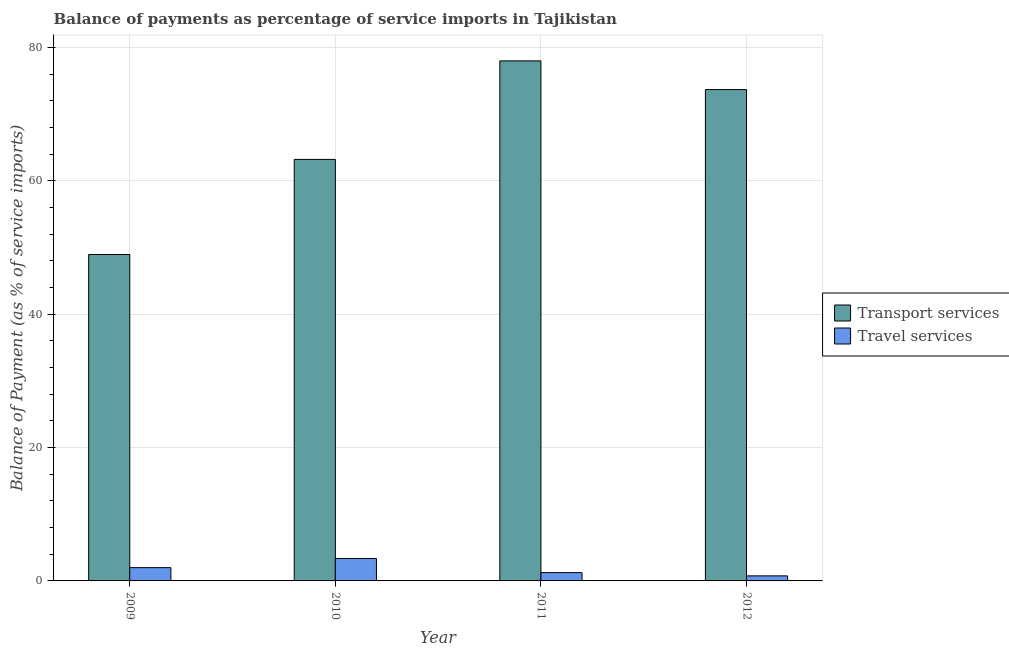How many groups of bars are there?
Your response must be concise. 4. Are the number of bars per tick equal to the number of legend labels?
Make the answer very short. Yes. What is the balance of payments of transport services in 2010?
Provide a short and direct response. 63.21. Across all years, what is the maximum balance of payments of travel services?
Provide a short and direct response. 3.36. Across all years, what is the minimum balance of payments of transport services?
Your answer should be compact. 48.95. In which year was the balance of payments of travel services maximum?
Offer a terse response. 2010. What is the total balance of payments of transport services in the graph?
Offer a terse response. 263.83. What is the difference between the balance of payments of transport services in 2009 and that in 2010?
Offer a very short reply. -14.26. What is the difference between the balance of payments of travel services in 2011 and the balance of payments of transport services in 2009?
Your response must be concise. -0.75. What is the average balance of payments of travel services per year?
Ensure brevity in your answer.  1.84. What is the ratio of the balance of payments of travel services in 2010 to that in 2012?
Provide a succinct answer. 4.44. Is the difference between the balance of payments of transport services in 2010 and 2011 greater than the difference between the balance of payments of travel services in 2010 and 2011?
Your answer should be very brief. No. What is the difference between the highest and the second highest balance of payments of travel services?
Offer a very short reply. 1.37. What is the difference between the highest and the lowest balance of payments of transport services?
Keep it short and to the point. 29.04. In how many years, is the balance of payments of travel services greater than the average balance of payments of travel services taken over all years?
Offer a terse response. 2. What does the 2nd bar from the left in 2010 represents?
Provide a succinct answer. Travel services. What does the 1st bar from the right in 2012 represents?
Your answer should be compact. Travel services. How many bars are there?
Provide a succinct answer. 8. How many years are there in the graph?
Offer a very short reply. 4. What is the difference between two consecutive major ticks on the Y-axis?
Provide a succinct answer. 20. Are the values on the major ticks of Y-axis written in scientific E-notation?
Offer a very short reply. No. Does the graph contain any zero values?
Your answer should be very brief. No. Does the graph contain grids?
Your answer should be compact. Yes. How many legend labels are there?
Your answer should be very brief. 2. How are the legend labels stacked?
Keep it short and to the point. Vertical. What is the title of the graph?
Provide a short and direct response. Balance of payments as percentage of service imports in Tajikistan. What is the label or title of the X-axis?
Keep it short and to the point. Year. What is the label or title of the Y-axis?
Your answer should be compact. Balance of Payment (as % of service imports). What is the Balance of Payment (as % of service imports) of Transport services in 2009?
Offer a very short reply. 48.95. What is the Balance of Payment (as % of service imports) of Travel services in 2009?
Offer a very short reply. 1.99. What is the Balance of Payment (as % of service imports) in Transport services in 2010?
Your response must be concise. 63.21. What is the Balance of Payment (as % of service imports) of Travel services in 2010?
Make the answer very short. 3.36. What is the Balance of Payment (as % of service imports) in Transport services in 2011?
Provide a succinct answer. 77.99. What is the Balance of Payment (as % of service imports) of Travel services in 2011?
Ensure brevity in your answer.  1.25. What is the Balance of Payment (as % of service imports) in Transport services in 2012?
Keep it short and to the point. 73.68. What is the Balance of Payment (as % of service imports) of Travel services in 2012?
Offer a terse response. 0.76. Across all years, what is the maximum Balance of Payment (as % of service imports) in Transport services?
Your response must be concise. 77.99. Across all years, what is the maximum Balance of Payment (as % of service imports) in Travel services?
Keep it short and to the point. 3.36. Across all years, what is the minimum Balance of Payment (as % of service imports) of Transport services?
Provide a succinct answer. 48.95. Across all years, what is the minimum Balance of Payment (as % of service imports) of Travel services?
Keep it short and to the point. 0.76. What is the total Balance of Payment (as % of service imports) of Transport services in the graph?
Offer a terse response. 263.83. What is the total Balance of Payment (as % of service imports) in Travel services in the graph?
Offer a terse response. 7.36. What is the difference between the Balance of Payment (as % of service imports) in Transport services in 2009 and that in 2010?
Keep it short and to the point. -14.26. What is the difference between the Balance of Payment (as % of service imports) in Travel services in 2009 and that in 2010?
Provide a short and direct response. -1.37. What is the difference between the Balance of Payment (as % of service imports) of Transport services in 2009 and that in 2011?
Your answer should be very brief. -29.04. What is the difference between the Balance of Payment (as % of service imports) in Travel services in 2009 and that in 2011?
Your answer should be compact. 0.75. What is the difference between the Balance of Payment (as % of service imports) in Transport services in 2009 and that in 2012?
Your response must be concise. -24.73. What is the difference between the Balance of Payment (as % of service imports) in Travel services in 2009 and that in 2012?
Offer a very short reply. 1.23. What is the difference between the Balance of Payment (as % of service imports) of Transport services in 2010 and that in 2011?
Your answer should be very brief. -14.78. What is the difference between the Balance of Payment (as % of service imports) in Travel services in 2010 and that in 2011?
Make the answer very short. 2.12. What is the difference between the Balance of Payment (as % of service imports) of Transport services in 2010 and that in 2012?
Offer a terse response. -10.47. What is the difference between the Balance of Payment (as % of service imports) in Travel services in 2010 and that in 2012?
Give a very brief answer. 2.61. What is the difference between the Balance of Payment (as % of service imports) of Transport services in 2011 and that in 2012?
Offer a terse response. 4.3. What is the difference between the Balance of Payment (as % of service imports) in Travel services in 2011 and that in 2012?
Offer a very short reply. 0.49. What is the difference between the Balance of Payment (as % of service imports) in Transport services in 2009 and the Balance of Payment (as % of service imports) in Travel services in 2010?
Give a very brief answer. 45.58. What is the difference between the Balance of Payment (as % of service imports) of Transport services in 2009 and the Balance of Payment (as % of service imports) of Travel services in 2011?
Your answer should be very brief. 47.7. What is the difference between the Balance of Payment (as % of service imports) in Transport services in 2009 and the Balance of Payment (as % of service imports) in Travel services in 2012?
Ensure brevity in your answer.  48.19. What is the difference between the Balance of Payment (as % of service imports) in Transport services in 2010 and the Balance of Payment (as % of service imports) in Travel services in 2011?
Offer a very short reply. 61.97. What is the difference between the Balance of Payment (as % of service imports) in Transport services in 2010 and the Balance of Payment (as % of service imports) in Travel services in 2012?
Your answer should be very brief. 62.45. What is the difference between the Balance of Payment (as % of service imports) in Transport services in 2011 and the Balance of Payment (as % of service imports) in Travel services in 2012?
Provide a short and direct response. 77.23. What is the average Balance of Payment (as % of service imports) in Transport services per year?
Your answer should be very brief. 65.96. What is the average Balance of Payment (as % of service imports) of Travel services per year?
Your response must be concise. 1.84. In the year 2009, what is the difference between the Balance of Payment (as % of service imports) of Transport services and Balance of Payment (as % of service imports) of Travel services?
Keep it short and to the point. 46.96. In the year 2010, what is the difference between the Balance of Payment (as % of service imports) in Transport services and Balance of Payment (as % of service imports) in Travel services?
Provide a succinct answer. 59.85. In the year 2011, what is the difference between the Balance of Payment (as % of service imports) of Transport services and Balance of Payment (as % of service imports) of Travel services?
Offer a very short reply. 76.74. In the year 2012, what is the difference between the Balance of Payment (as % of service imports) in Transport services and Balance of Payment (as % of service imports) in Travel services?
Offer a very short reply. 72.92. What is the ratio of the Balance of Payment (as % of service imports) in Transport services in 2009 to that in 2010?
Provide a short and direct response. 0.77. What is the ratio of the Balance of Payment (as % of service imports) of Travel services in 2009 to that in 2010?
Offer a very short reply. 0.59. What is the ratio of the Balance of Payment (as % of service imports) in Transport services in 2009 to that in 2011?
Provide a short and direct response. 0.63. What is the ratio of the Balance of Payment (as % of service imports) in Travel services in 2009 to that in 2011?
Offer a terse response. 1.6. What is the ratio of the Balance of Payment (as % of service imports) of Transport services in 2009 to that in 2012?
Offer a terse response. 0.66. What is the ratio of the Balance of Payment (as % of service imports) of Travel services in 2009 to that in 2012?
Your answer should be compact. 2.63. What is the ratio of the Balance of Payment (as % of service imports) of Transport services in 2010 to that in 2011?
Provide a succinct answer. 0.81. What is the ratio of the Balance of Payment (as % of service imports) in Travel services in 2010 to that in 2011?
Provide a succinct answer. 2.7. What is the ratio of the Balance of Payment (as % of service imports) of Transport services in 2010 to that in 2012?
Offer a terse response. 0.86. What is the ratio of the Balance of Payment (as % of service imports) in Travel services in 2010 to that in 2012?
Make the answer very short. 4.44. What is the ratio of the Balance of Payment (as % of service imports) in Transport services in 2011 to that in 2012?
Your response must be concise. 1.06. What is the ratio of the Balance of Payment (as % of service imports) in Travel services in 2011 to that in 2012?
Offer a very short reply. 1.64. What is the difference between the highest and the second highest Balance of Payment (as % of service imports) in Transport services?
Provide a short and direct response. 4.3. What is the difference between the highest and the second highest Balance of Payment (as % of service imports) of Travel services?
Ensure brevity in your answer.  1.37. What is the difference between the highest and the lowest Balance of Payment (as % of service imports) in Transport services?
Offer a very short reply. 29.04. What is the difference between the highest and the lowest Balance of Payment (as % of service imports) in Travel services?
Provide a succinct answer. 2.61. 